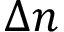Convert formula to latex. <formula><loc_0><loc_0><loc_500><loc_500>\Delta n</formula> 